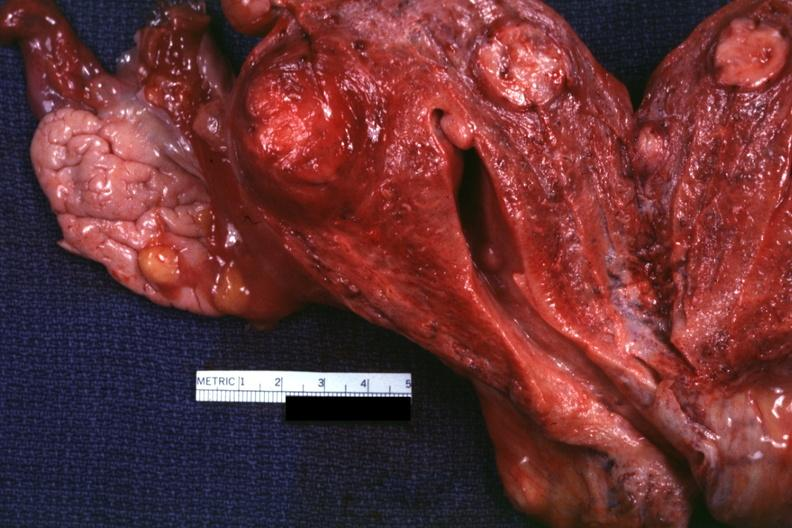what is present?
Answer the question using a single word or phrase. Leiomyoma 